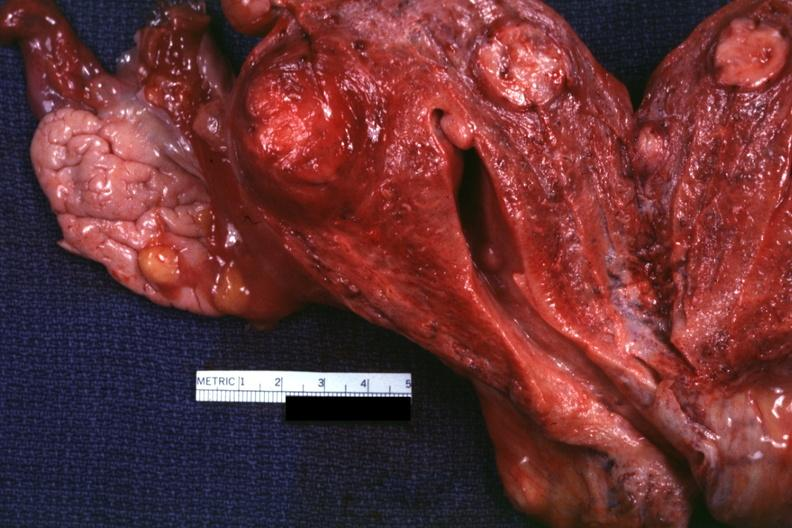what is present?
Answer the question using a single word or phrase. Leiomyoma 